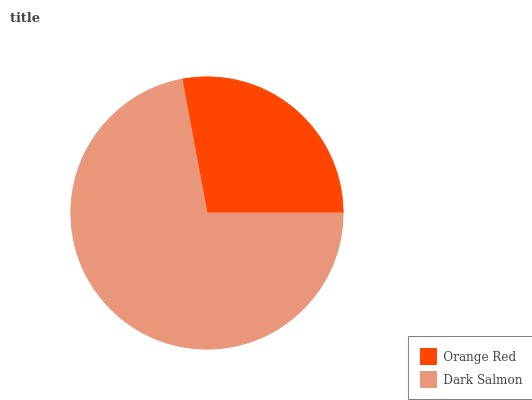Is Orange Red the minimum?
Answer yes or no. Yes. Is Dark Salmon the maximum?
Answer yes or no. Yes. Is Dark Salmon the minimum?
Answer yes or no. No. Is Dark Salmon greater than Orange Red?
Answer yes or no. Yes. Is Orange Red less than Dark Salmon?
Answer yes or no. Yes. Is Orange Red greater than Dark Salmon?
Answer yes or no. No. Is Dark Salmon less than Orange Red?
Answer yes or no. No. Is Dark Salmon the high median?
Answer yes or no. Yes. Is Orange Red the low median?
Answer yes or no. Yes. Is Orange Red the high median?
Answer yes or no. No. Is Dark Salmon the low median?
Answer yes or no. No. 